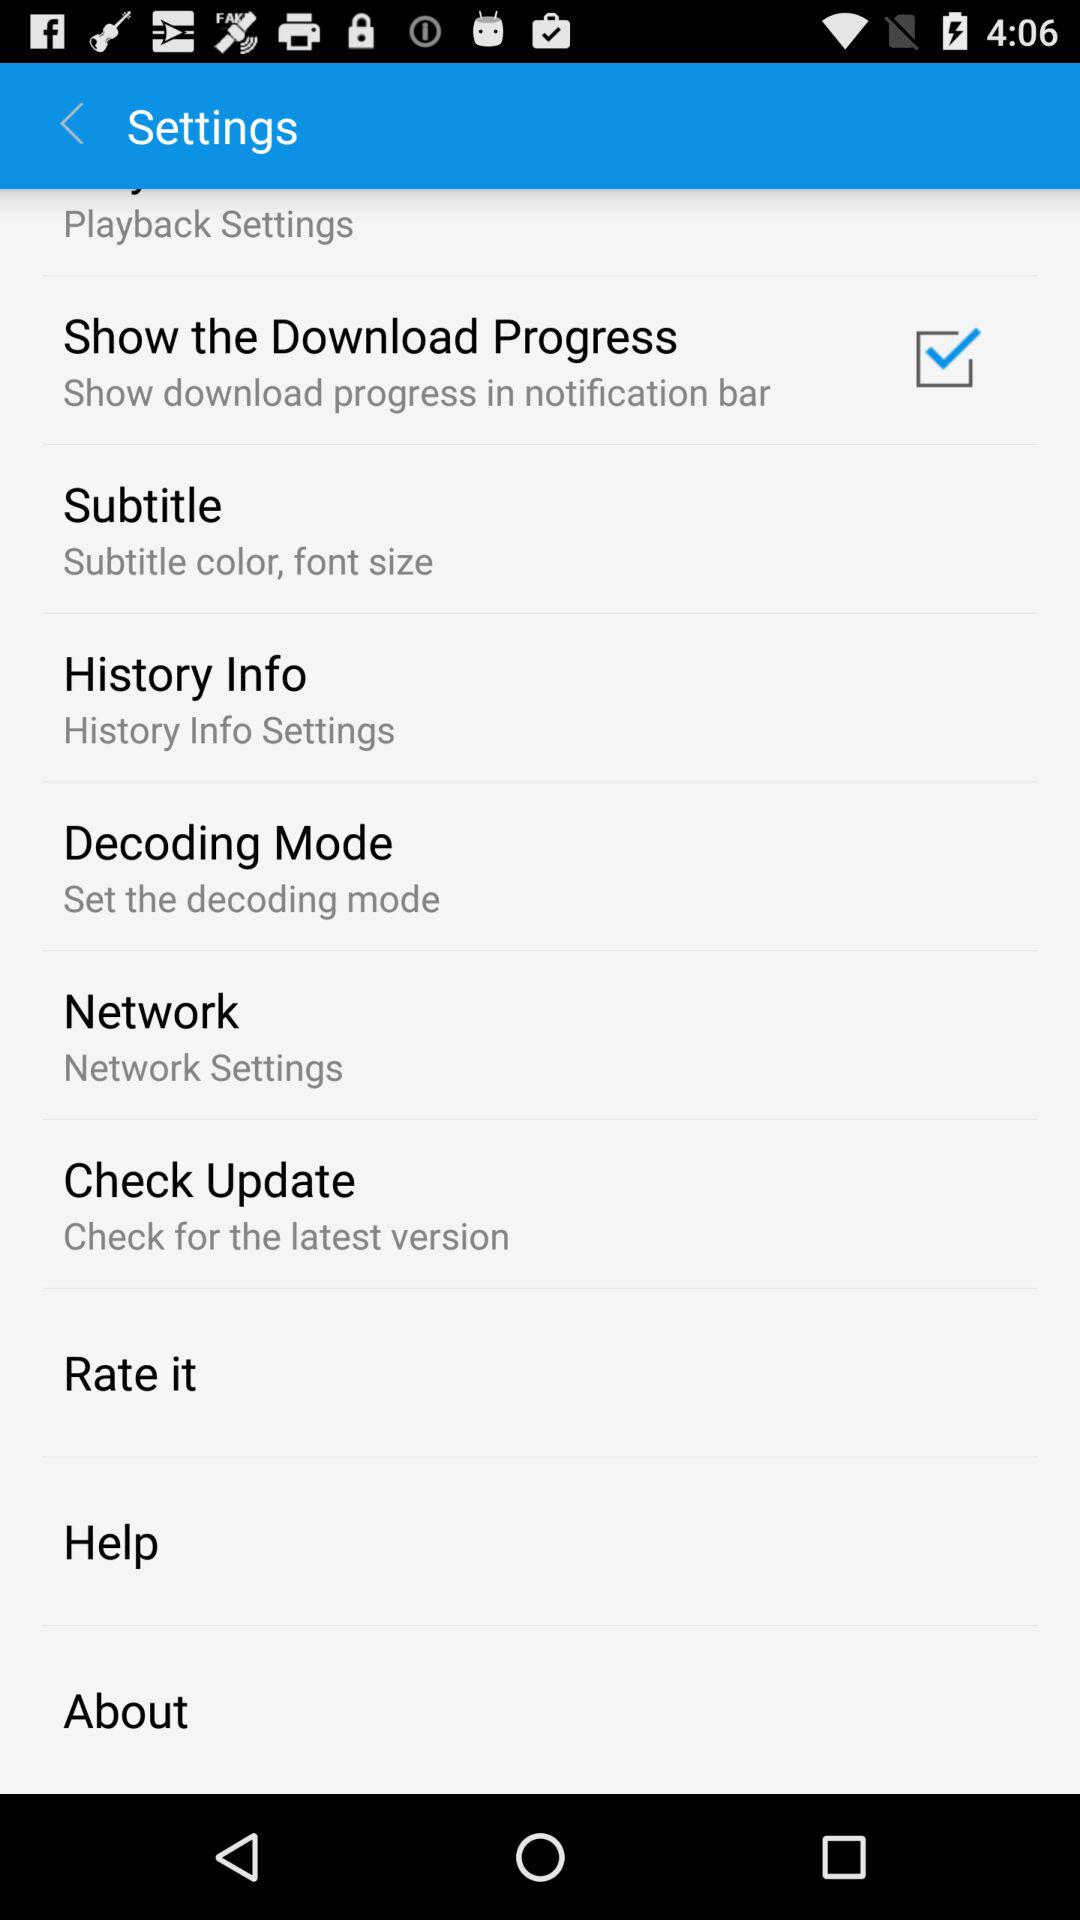Check for the latest version option is selected in which setting?
When the provided information is insufficient, respond with <no answer>. <no answer> 